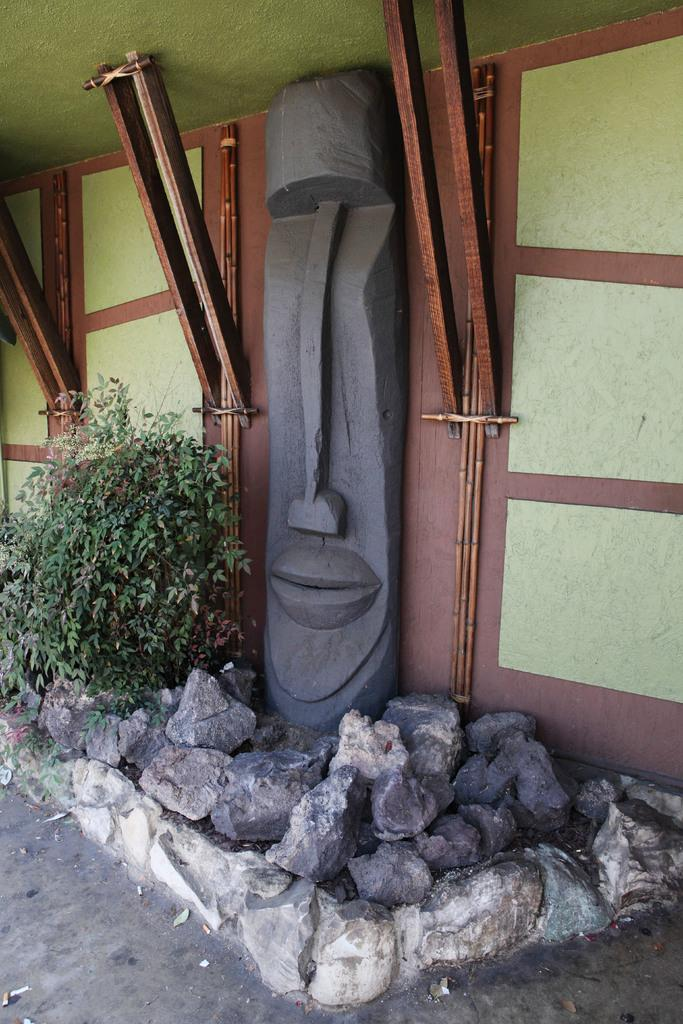What is the main structure in the center of the image? There is a wall in the center of the image. What is attached to the wall? There is a sculpture on the wall. What can be seen at the bottom of the image? There are rocks and a plant at the bottom of the image. What type of light can be seen emanating from the earth in the image? There is no light emanating from the earth in the image, as the facts provided do not mention any light source. 